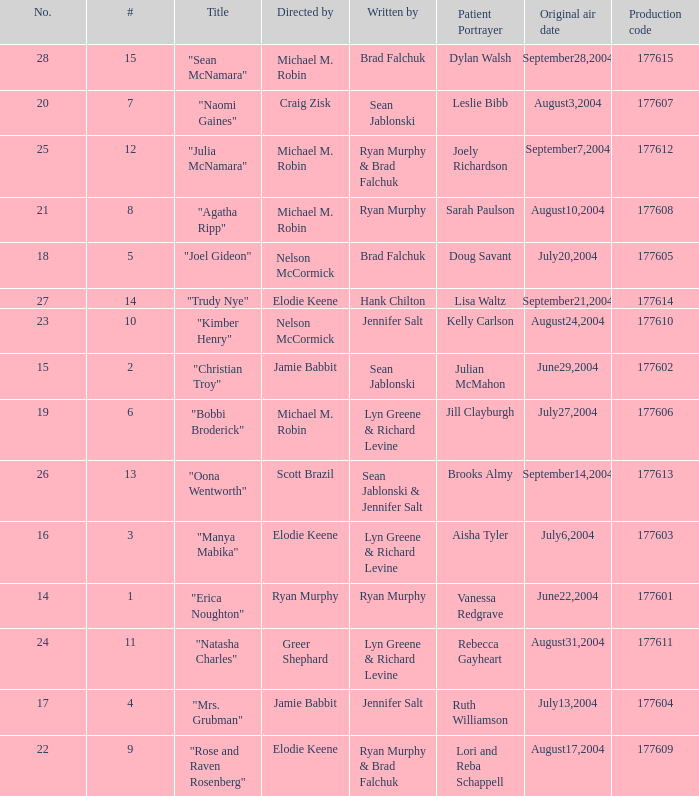Who wrote episode number 28? Brad Falchuk. 